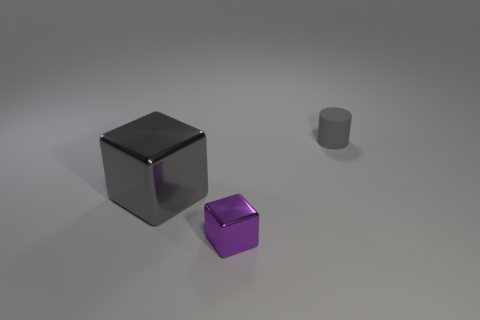What is the size of the block that is the same color as the cylinder?
Your answer should be very brief. Large. Is there a tiny matte cylinder of the same color as the big shiny thing?
Give a very brief answer. Yes. What number of other objects are there of the same shape as the small matte thing?
Make the answer very short. 0. What shape is the small thing that is in front of the large metal block?
Make the answer very short. Cube. Is the shape of the big thing the same as the metal thing in front of the large gray metallic object?
Give a very brief answer. Yes. There is a object that is both right of the big gray thing and in front of the gray rubber object; how big is it?
Keep it short and to the point. Small. The object that is behind the purple block and right of the gray metallic block is what color?
Your answer should be very brief. Gray. Is there any other thing that has the same material as the tiny cylinder?
Your answer should be very brief. No. Is the number of big gray things that are to the left of the large block less than the number of small metal blocks behind the cylinder?
Your response must be concise. No. Is there any other thing that is the same color as the small cylinder?
Ensure brevity in your answer.  Yes. 